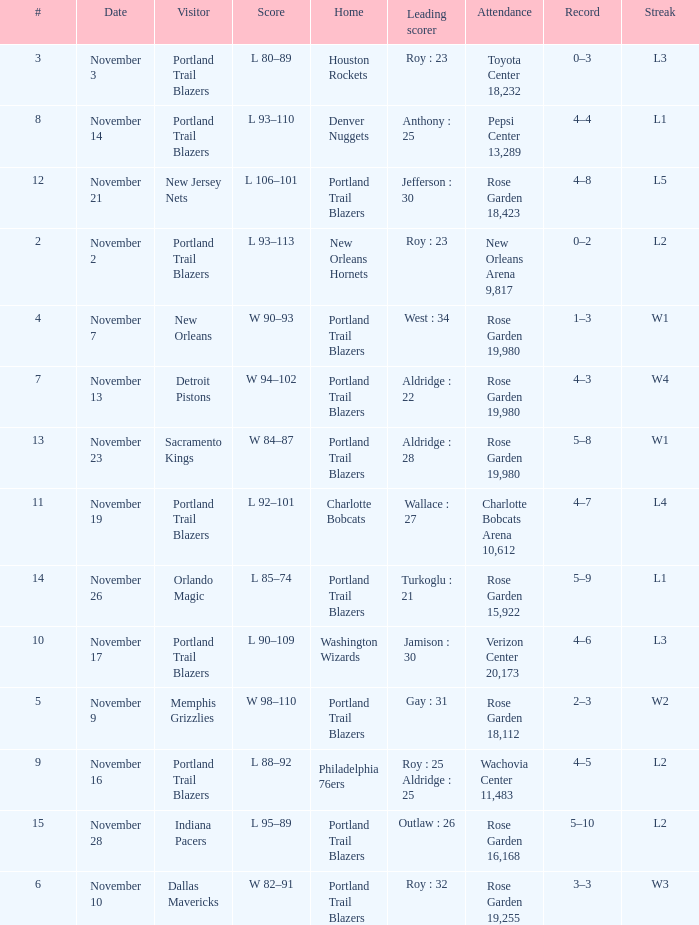 what's the home team where streak is l3 and leading scorer is roy : 23 Houston Rockets. 